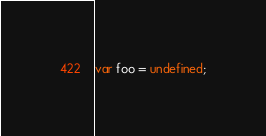<code> <loc_0><loc_0><loc_500><loc_500><_JavaScript_>var foo = undefined;
</code> 